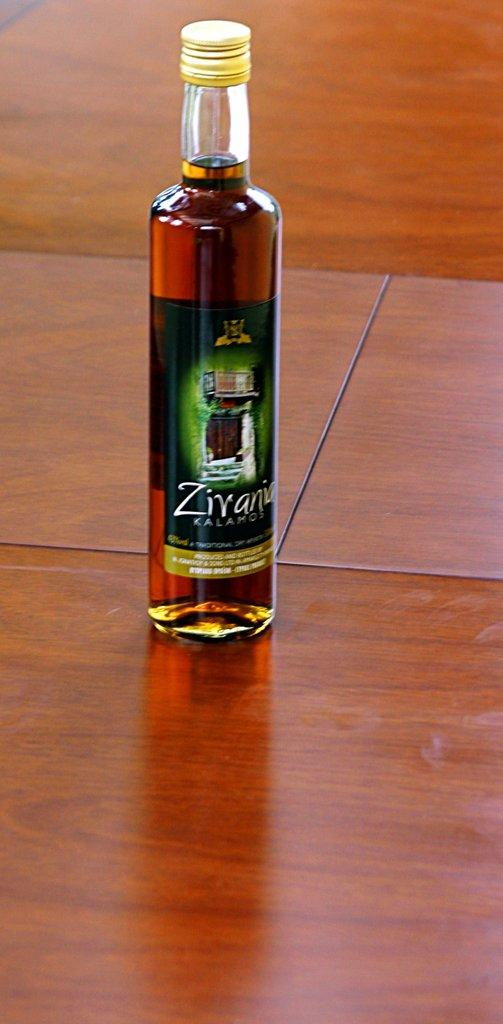<image>
Relay a brief, clear account of the picture shown. A bottle of Zirania Kalamos sits on a wooden table. 